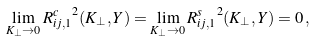<formula> <loc_0><loc_0><loc_500><loc_500>\lim _ { K _ { \perp } \to 0 } { R _ { i j , 1 } ^ { c } } ^ { 2 } ( K _ { \perp } , Y ) = \lim _ { K _ { \perp } \to 0 } { R _ { i j , 1 } ^ { s } } ^ { 2 } ( K _ { \perp } , Y ) = 0 \, ,</formula> 